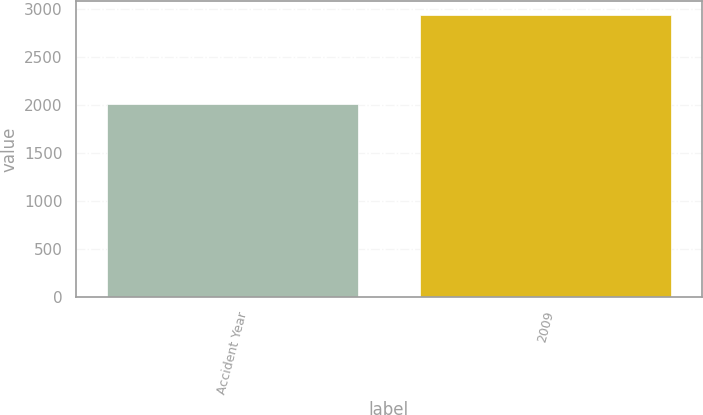<chart> <loc_0><loc_0><loc_500><loc_500><bar_chart><fcel>Accident Year<fcel>2009<nl><fcel>2015<fcel>2939<nl></chart> 